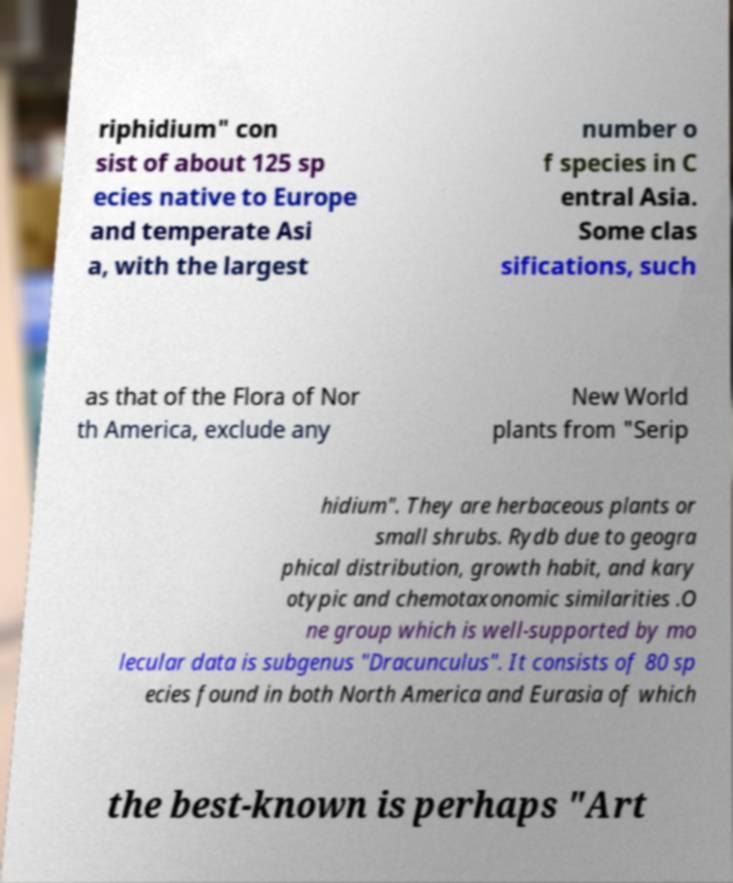For documentation purposes, I need the text within this image transcribed. Could you provide that? riphidium" con sist of about 125 sp ecies native to Europe and temperate Asi a, with the largest number o f species in C entral Asia. Some clas sifications, such as that of the Flora of Nor th America, exclude any New World plants from "Serip hidium". They are herbaceous plants or small shrubs. Rydb due to geogra phical distribution, growth habit, and kary otypic and chemotaxonomic similarities .O ne group which is well-supported by mo lecular data is subgenus "Dracunculus". It consists of 80 sp ecies found in both North America and Eurasia of which the best-known is perhaps "Art 